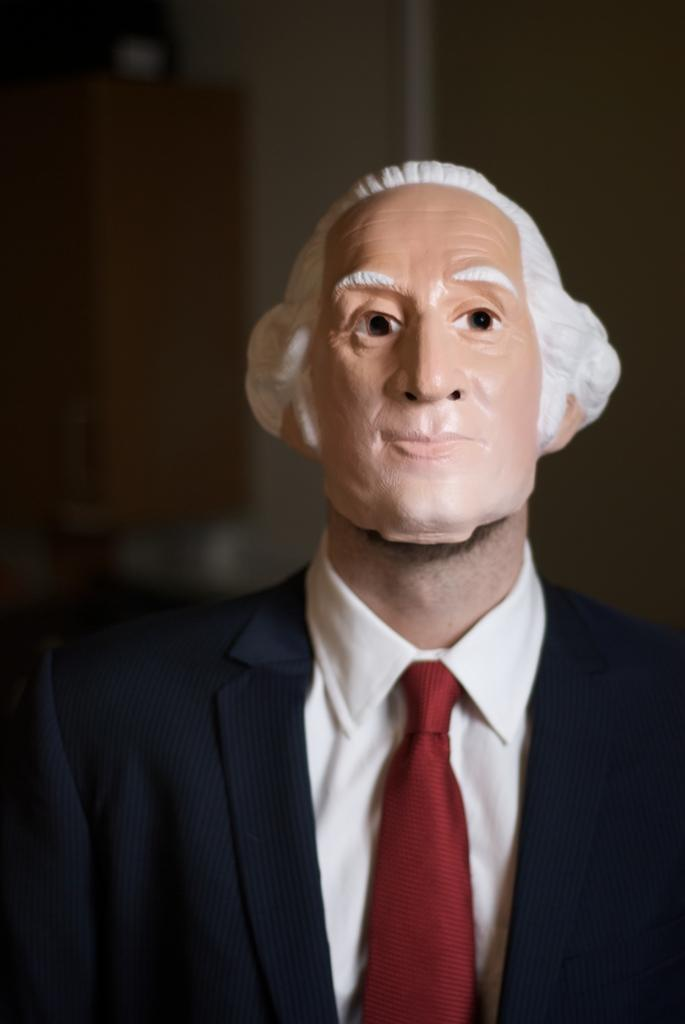What can be seen in the image? There is a person in the image. Can you describe the person's appearance? The person is wearing a mask. What can be observed about the background of the image? The background of the image is blurred. What type of pets are visible in the image? There are no pets visible in the image. Is there a bomb present in the image? There is no bomb present in the image. 